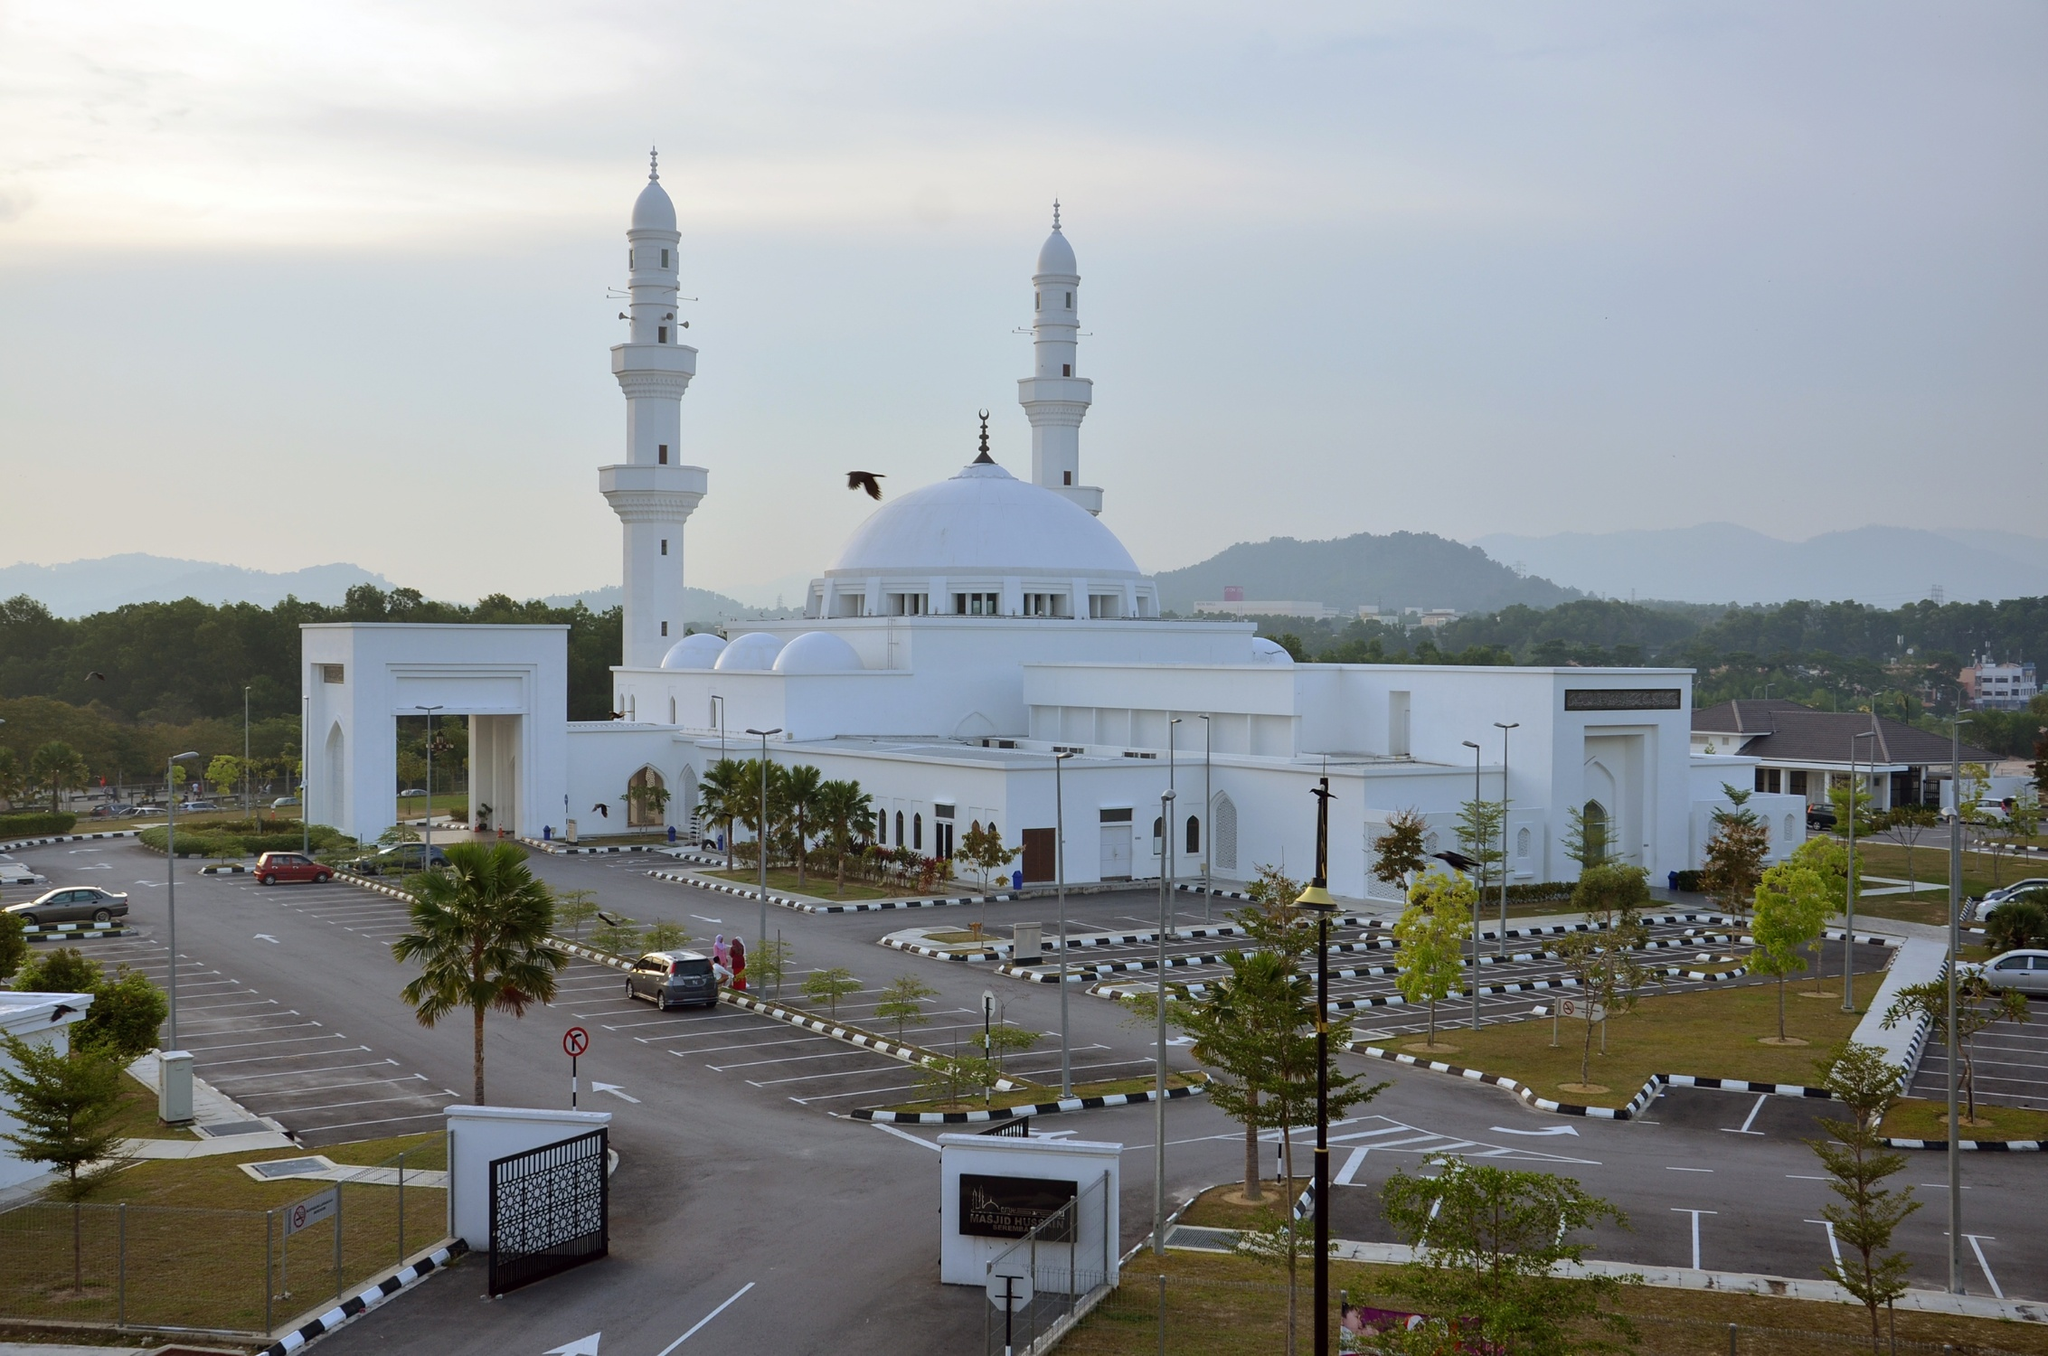What is the historical significance of the Tengku Ampuan Jemaah Mosque? The Tengku Ampuan Jemaah Mosque, located in Bukit Jelutong, Malaysia, is named after the late Tengku Ampuan Jemaah, who was the consort of the Sultan of Selangor. This mosque, inaugurated to serve the community, stands as a testament to the rich cultural and religious heritage of the region. Its architectural design is a blend of Malay and Islamic influences, reflecting the historical and cultural tapestry of Malaysia. The mosque not only serves as a place of worship but also acts as a hub for educational and social activities, fostering community spirit and continuity of cultural traditions. Can you describe the architectural elements of the mosque in detail? Absolutely! The Tengku Ampuan Jemaah Mosque showcases classic Islamic architectural elements. The central feature is its grand dome, which is flanked by four smaller domes, symbolizing the heavens and celestial bodies. The two minarets stand tall, serving both a spiritual purpose of calling the faithful to prayer and aesthetically balancing the mosque’s presence. The mosque is adorned with intricate geometric patterns and calligraphy, reflecting the artistry of Islamic tradition. The use of arches and columns, both for structural support and decoration, is prominent. White being its dominant color, the mosque reflects purity and peace, enhancing its serene ambiance. The landscaped garden and surrounding greenery, along with the strategic use of open space and light, make the mosque not just a religious edifice but a serene retreat for contemplation. Imagine if the mosque could talk, what stories might it share from its past? If the Tengku Ampuan Jemaah Mosque could talk, it would narrate tales of faith and devotion. It would recount the joyous sounds of children learning in its madrasah, the whispers of prayers offered in quiet contemplation, and the echoes of community gatherings that have shaped its essence. It might share memories of the day it was inaugurated with grandeur and the pride of its community standing united in celebration. The mosque would speak of its role as a sanctuary during times of individual and collective hardship, offering comfort and hope. At times of festival, it would describe the vibrant scenes of togetherness and jubilation that bring its surroundings to life. 